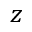Convert formula to latex. <formula><loc_0><loc_0><loc_500><loc_500>z</formula> 